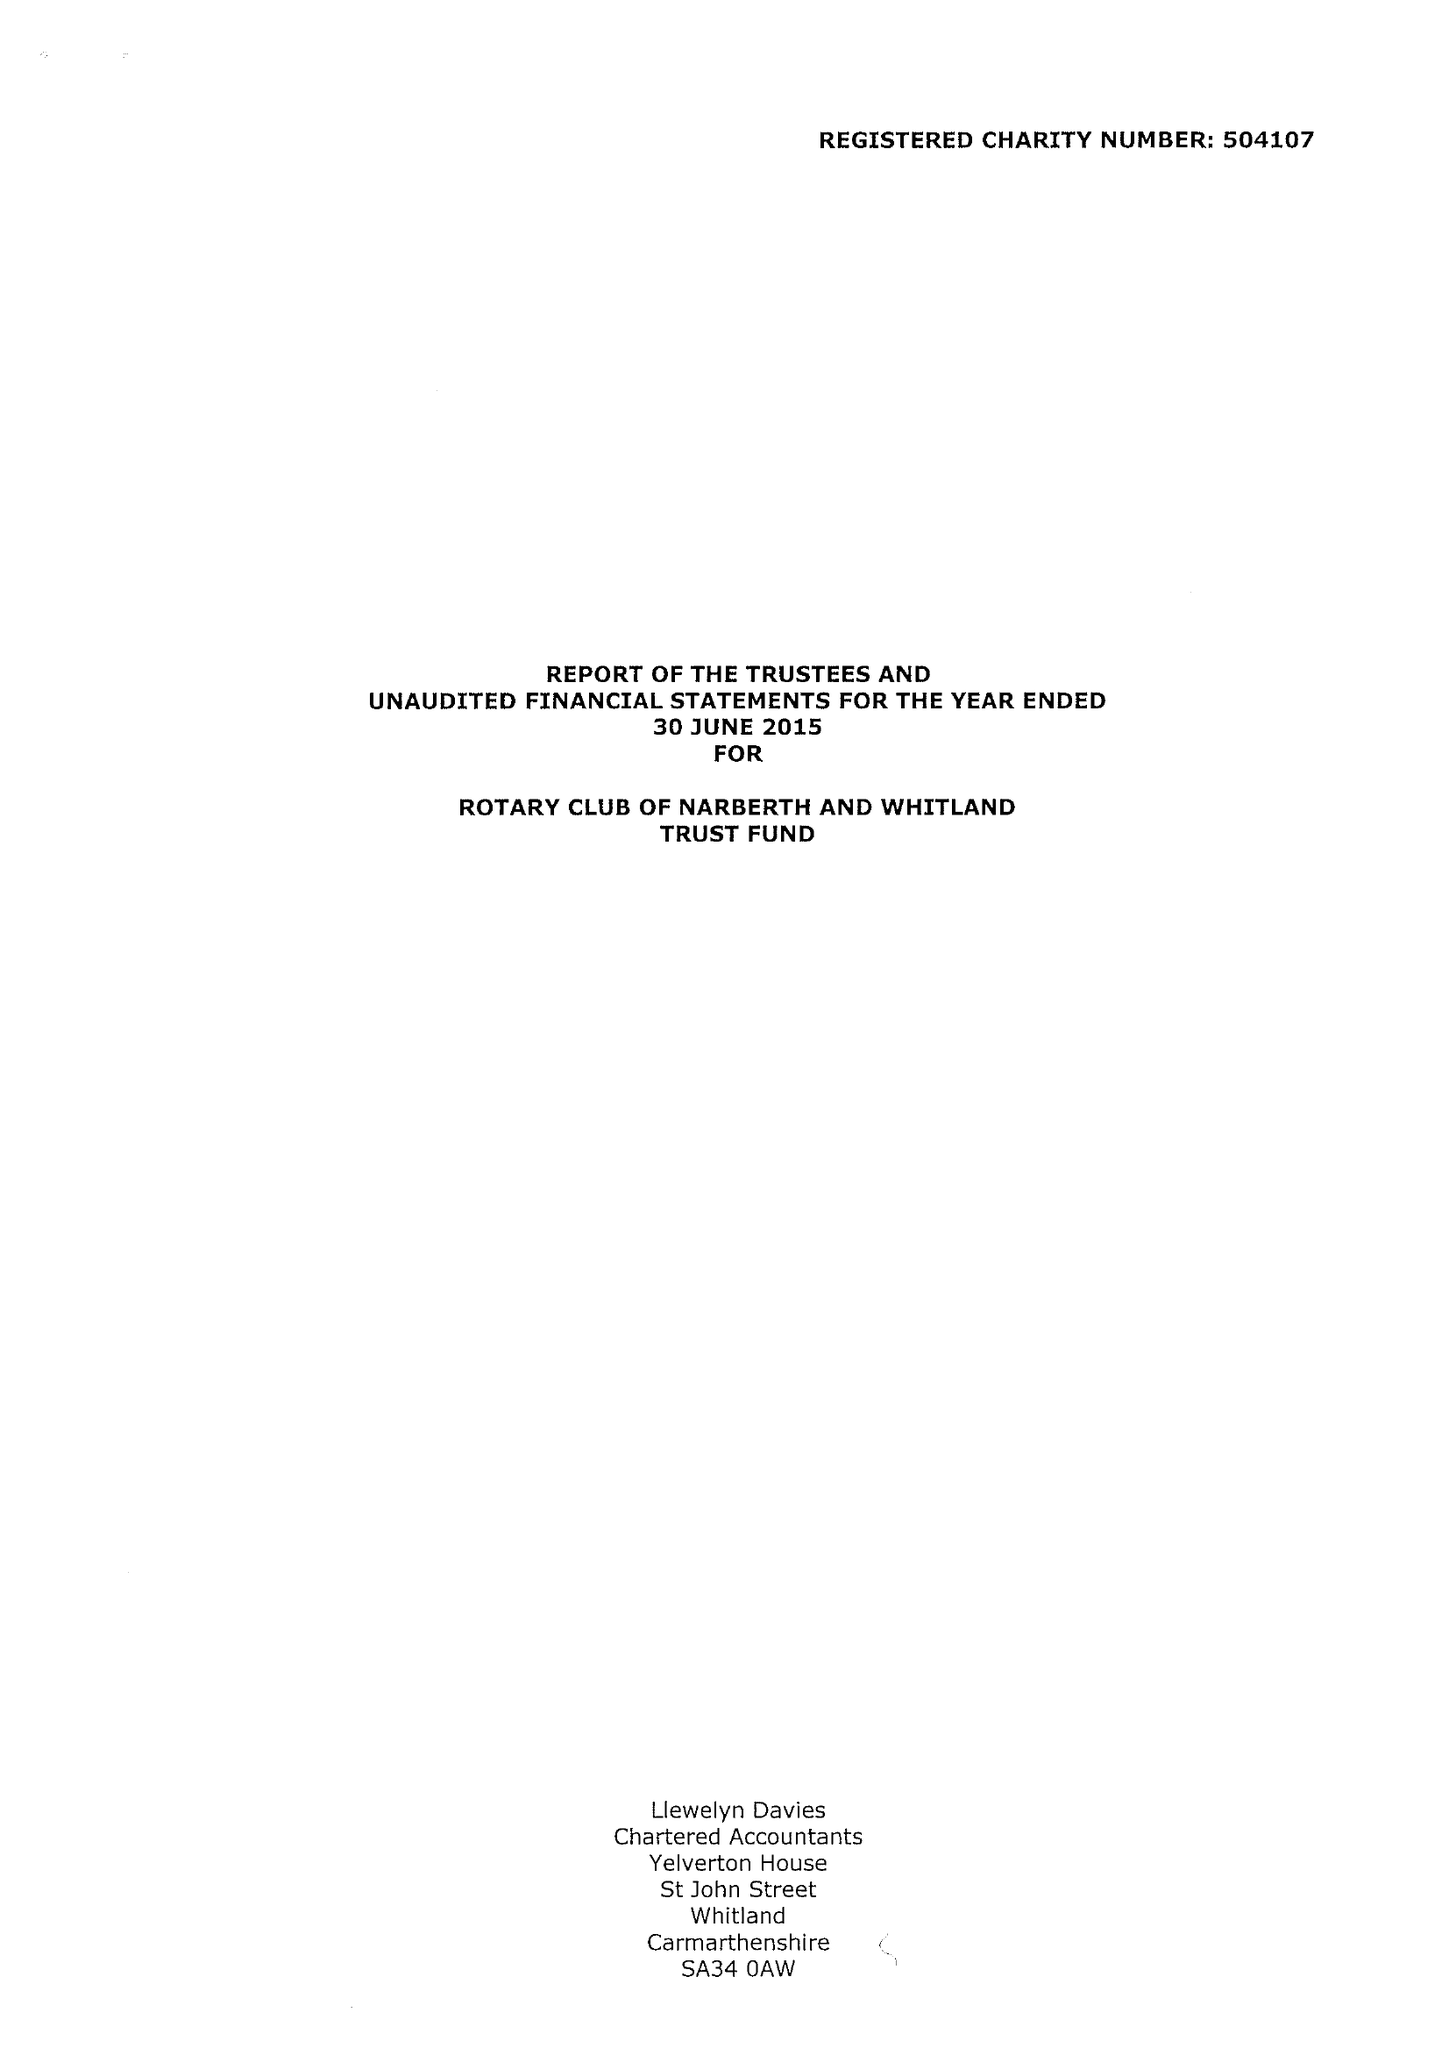What is the value for the charity_name?
Answer the question using a single word or phrase. Rotary Club Of Narberth and Whitland Trust Fund 